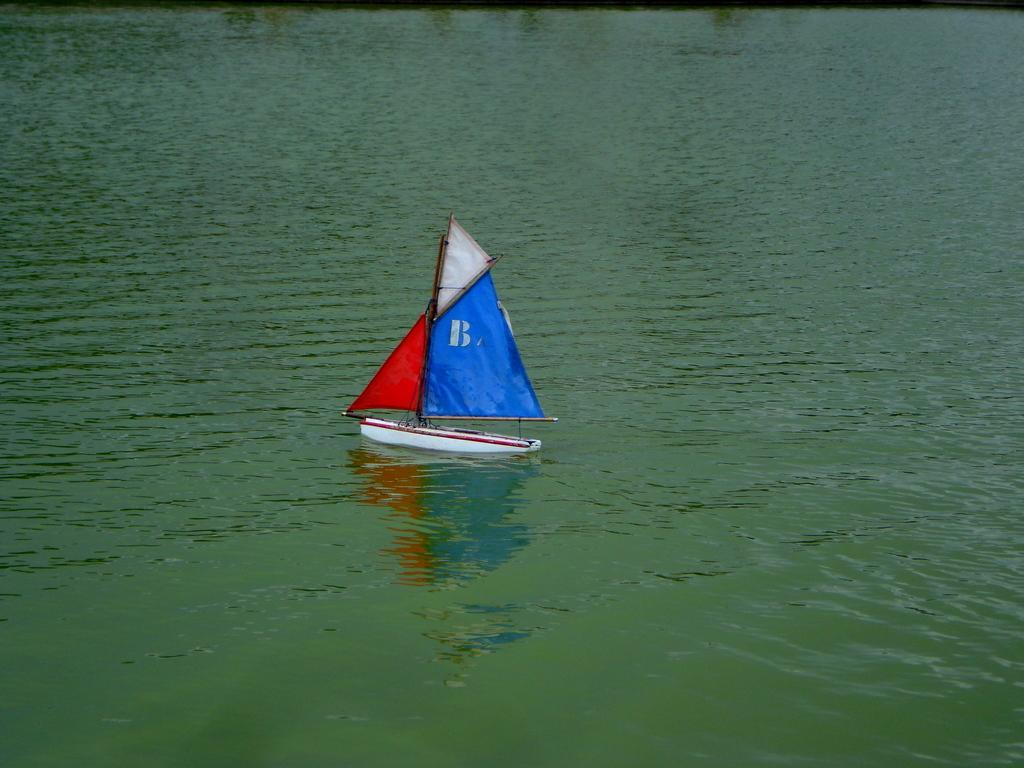Describe this image in one or two sentences. In this image I can see the water which are green in color and a boat which is white , red and blue in color on the surface of the water. 